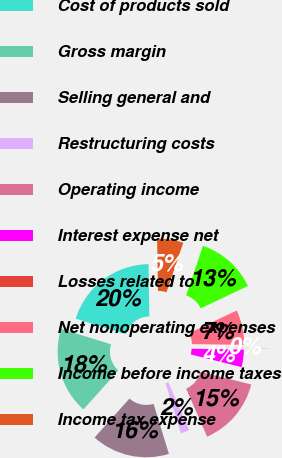Convert chart to OTSL. <chart><loc_0><loc_0><loc_500><loc_500><pie_chart><fcel>Cost of products sold<fcel>Gross margin<fcel>Selling general and<fcel>Restructuring costs<fcel>Operating income<fcel>Interest expense net<fcel>Losses related to<fcel>Net nonoperating expenses<fcel>Income before income taxes<fcel>Income tax expense<nl><fcel>19.97%<fcel>18.16%<fcel>16.35%<fcel>1.84%<fcel>14.53%<fcel>3.65%<fcel>0.03%<fcel>7.28%<fcel>12.72%<fcel>5.47%<nl></chart> 